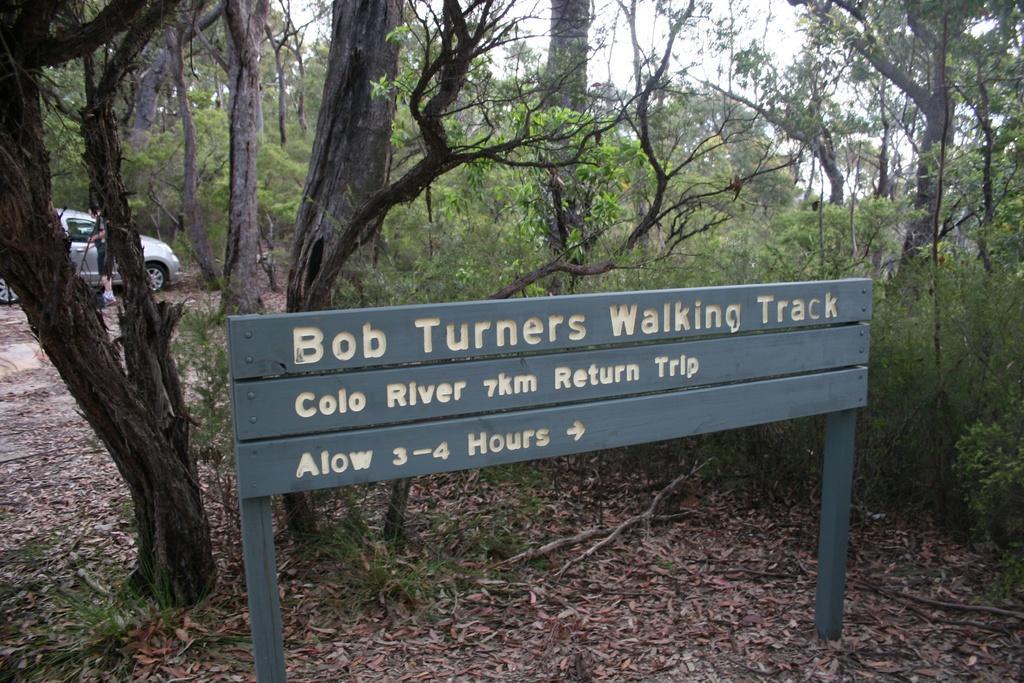Could you give a brief overview of what you see in this image? In this image we can see information board, shredded leaves on the ground, trees, motor vehicle, person standing, pond and sky. 